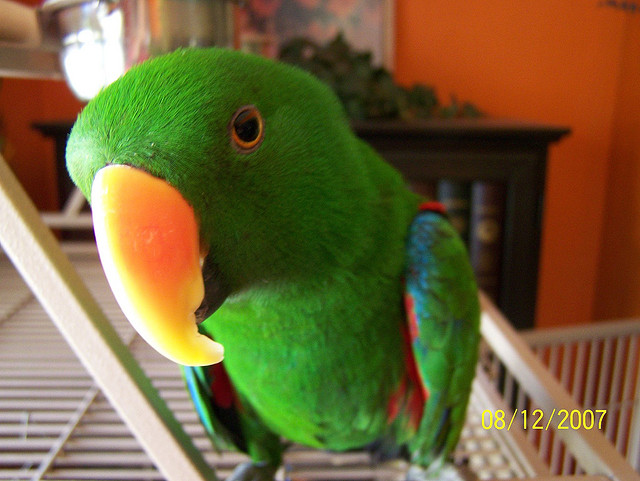Please identify all text content in this image. 08 12 2007 